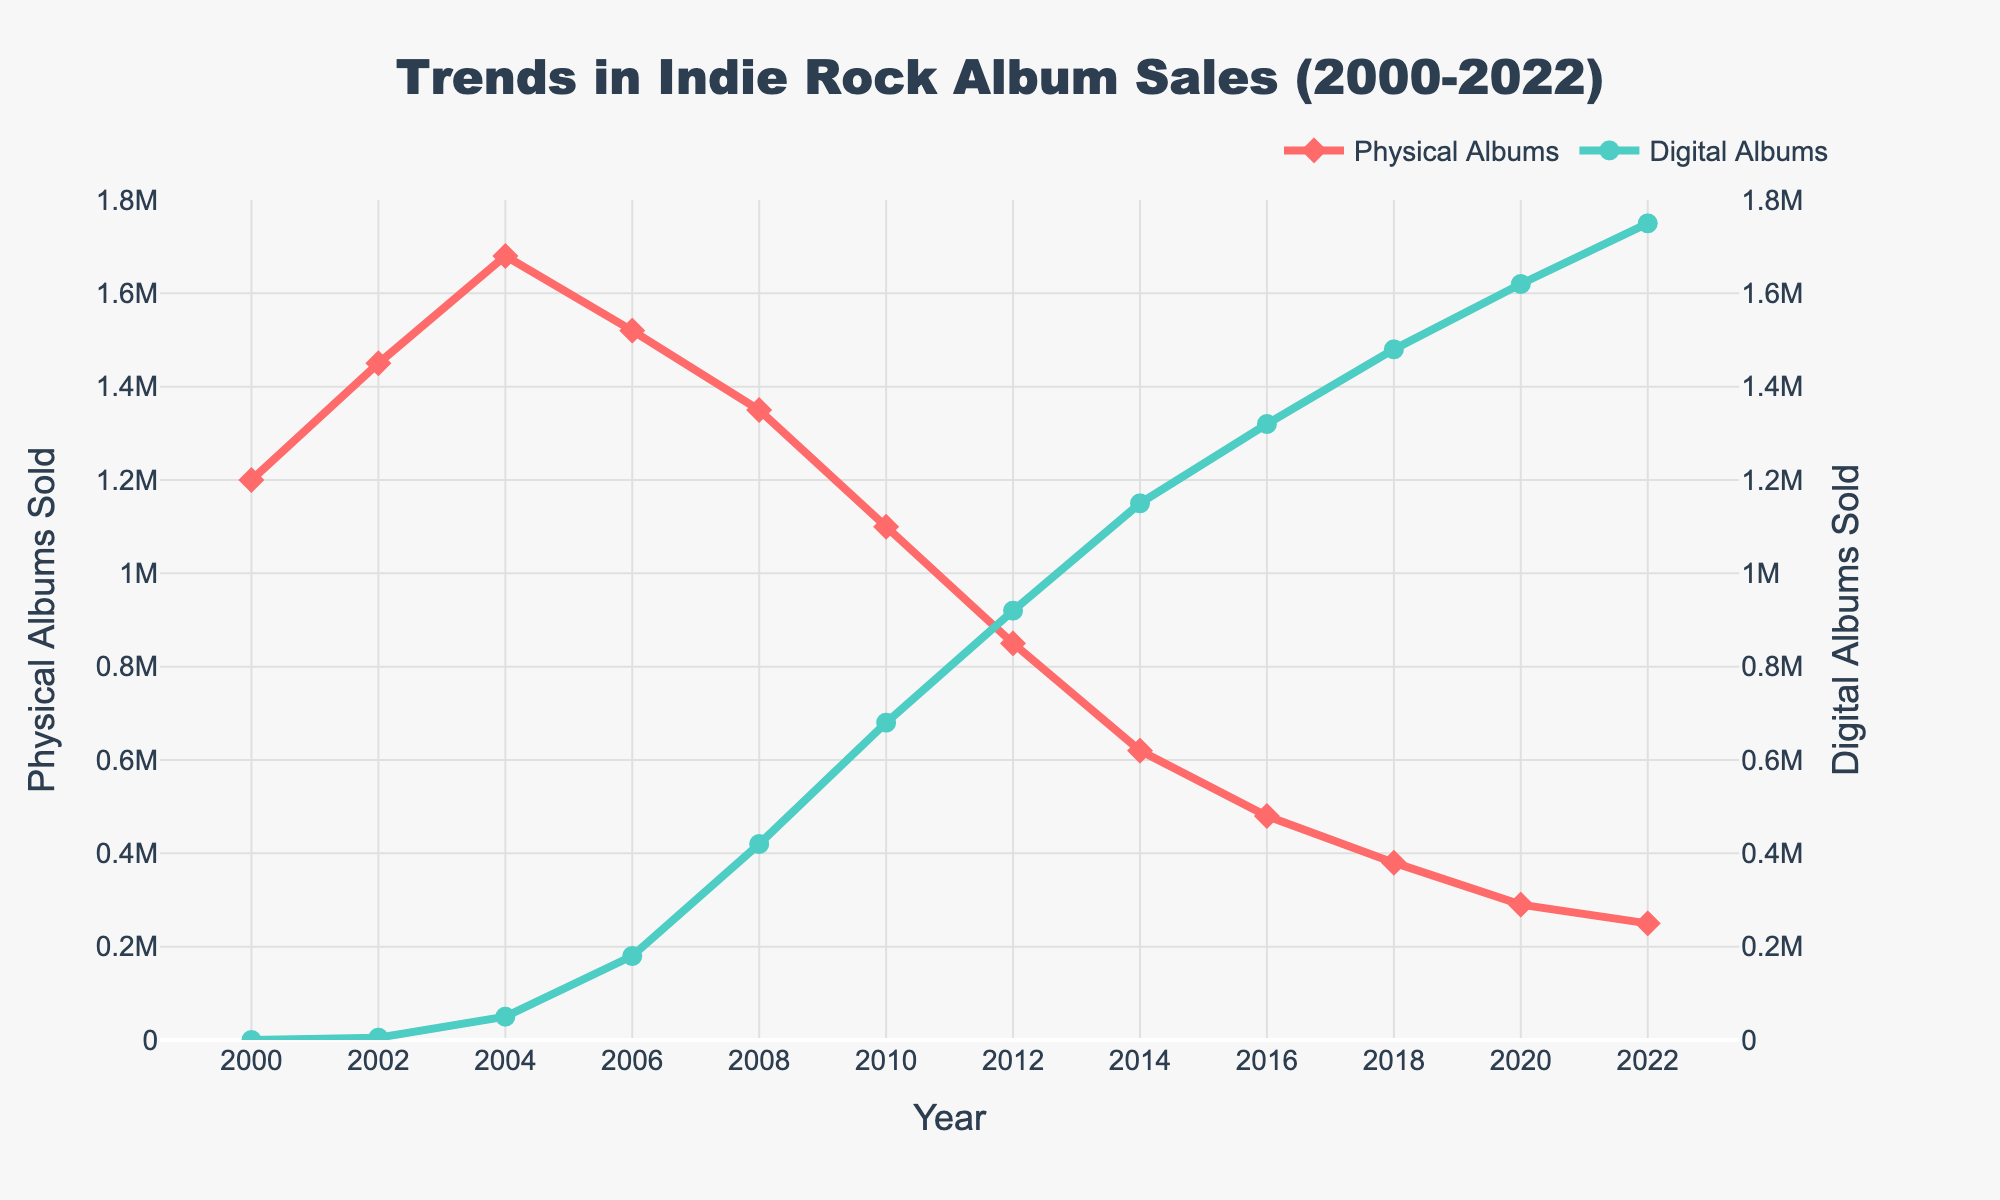When did digital album sales exceed physical album sales? In 2014, the sales of physical albums were 620,000, while digital album sales were 1,150,000, indicating that digital album sales had surpassed physical album sales.
Answer: 2014 Which year had the highest sales for physical albums, and what were the sales figures? The year 2004 had the highest sales of physical albums at 1,680,000.
Answer: 2004, 1,680,000 What is the difference in sales between physical and digital albums in the year 2022? In 2022, physical album sales were 250,000, and digital album sales were 1,750,000. The difference is 1,750,000 - 250,000 = 1,500,000.
Answer: 1,500,000 How did the sales of physical albums change from 2000 to 2010? In 2000, physical album sales were 1,200,000, while in 2010, it was 1,100,000. The decline from 2000 to 2010 is 1,200,000 - 1,100,000 = 100,000.
Answer: Decreased by 100,000 Which album format had more sales in 2018, and what are the figures? In 2018, physical album sales were 380,000, and digital album sales were 1,480,000. Digital albums had higher sales.
Answer: Digital albums, 1,480,000 What is the average growth rate of digital albums between 2000 and 2008? In 2000, digital album sales were 0. By 2008, digital album sales were 420,000. The average growth rate is 420,000 / 8 years = 52,500 per year.
Answer: 52,500 per year Compare the trends of physical and digital albums from 2004 to 2012. Physical albums decreased from 1,680,000 in 2004 to 850,000 in 2012, a decline of 830,000. Digital albums increased from 50,000 in 2004 to 920,000 in 2012, a growth of 870,000.
Answer: Physical: Decreased by 830,000; Digital: Increased by 870,000 What is the combined sales figure for physical and digital albums in 2020? In 2020, physical album sales were 290,000, and digital album sales were 1,620,000. The combined sales are 290,000 + 1,620,000 = 1,910,000.
Answer: 1,910,000 Describe the visual change in digital album sales from 2006 to 2016. Digital album sales increased significantly, starting from 180,000 in 2006 to 1,320,000 in 2016. The green line representing digital albums rises sharply.
Answer: Sharp increase 